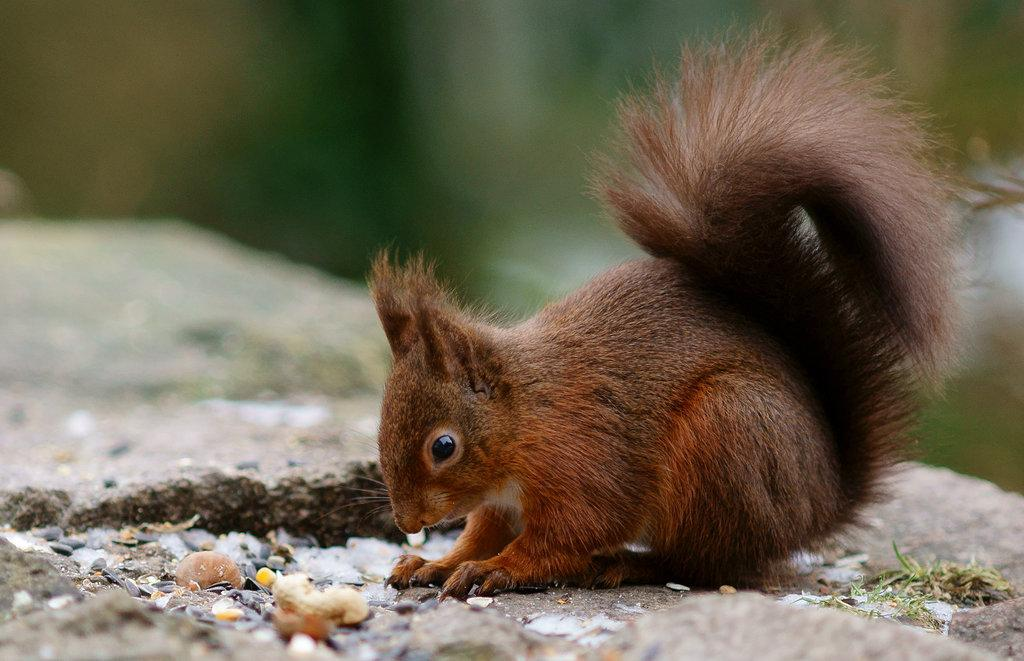What type of animal is in the image? There is a brown squirrel in the image. Where is the squirrel located? The squirrel is on a surface. Can you describe the background of the image? The background of the image is blurred. What type of drink is the squirrel holding in the image? The squirrel is not holding any drink in the image; it is a squirrel, not a person. 